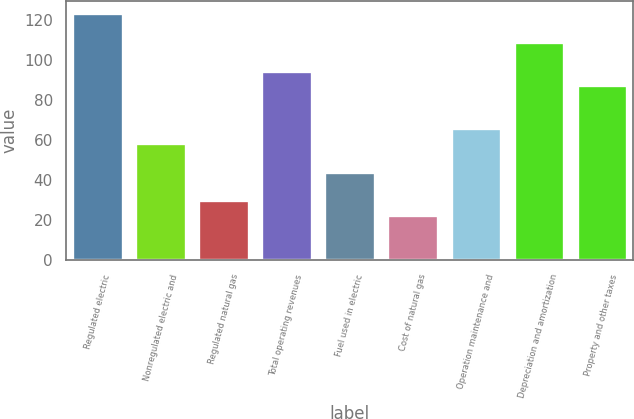<chart> <loc_0><loc_0><loc_500><loc_500><bar_chart><fcel>Regulated electric<fcel>Nonregulated electric and<fcel>Regulated natural gas<fcel>Total operating revenues<fcel>Fuel used in electric<fcel>Cost of natural gas<fcel>Operation maintenance and<fcel>Depreciation and amortization<fcel>Property and other taxes<nl><fcel>123.4<fcel>58.6<fcel>29.8<fcel>94.6<fcel>44.2<fcel>22.6<fcel>65.8<fcel>109<fcel>87.4<nl></chart> 